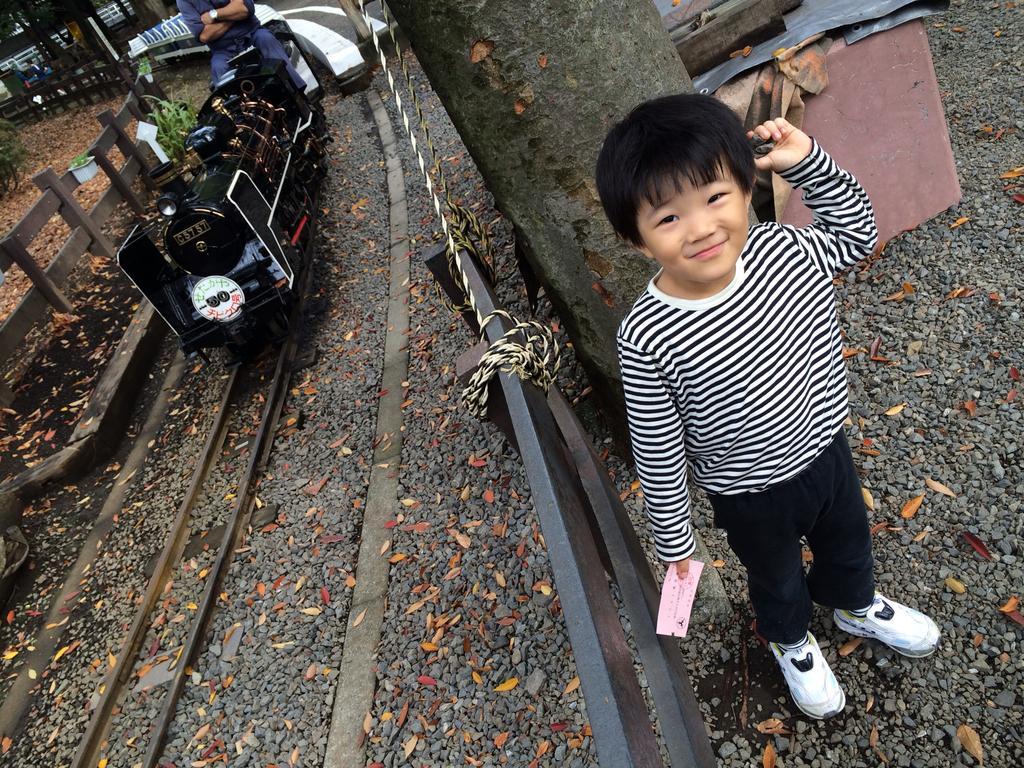Describe this image in one or two sentences. In this image a boy is standing on the land. Behind him there is a wooden trunk. Left side there is a miniature train on the track. Beside there is a fence. A person is sitting on the train. Left side there is a plant. Right side there are few objects on the land. Beside the boy there is fence tied with rope. 